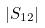<formula> <loc_0><loc_0><loc_500><loc_500>| S _ { 1 2 } |</formula> 